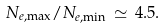Convert formula to latex. <formula><loc_0><loc_0><loc_500><loc_500>N _ { e , \max } / N _ { e , \min } \, \simeq \, 4 . 5 .</formula> 